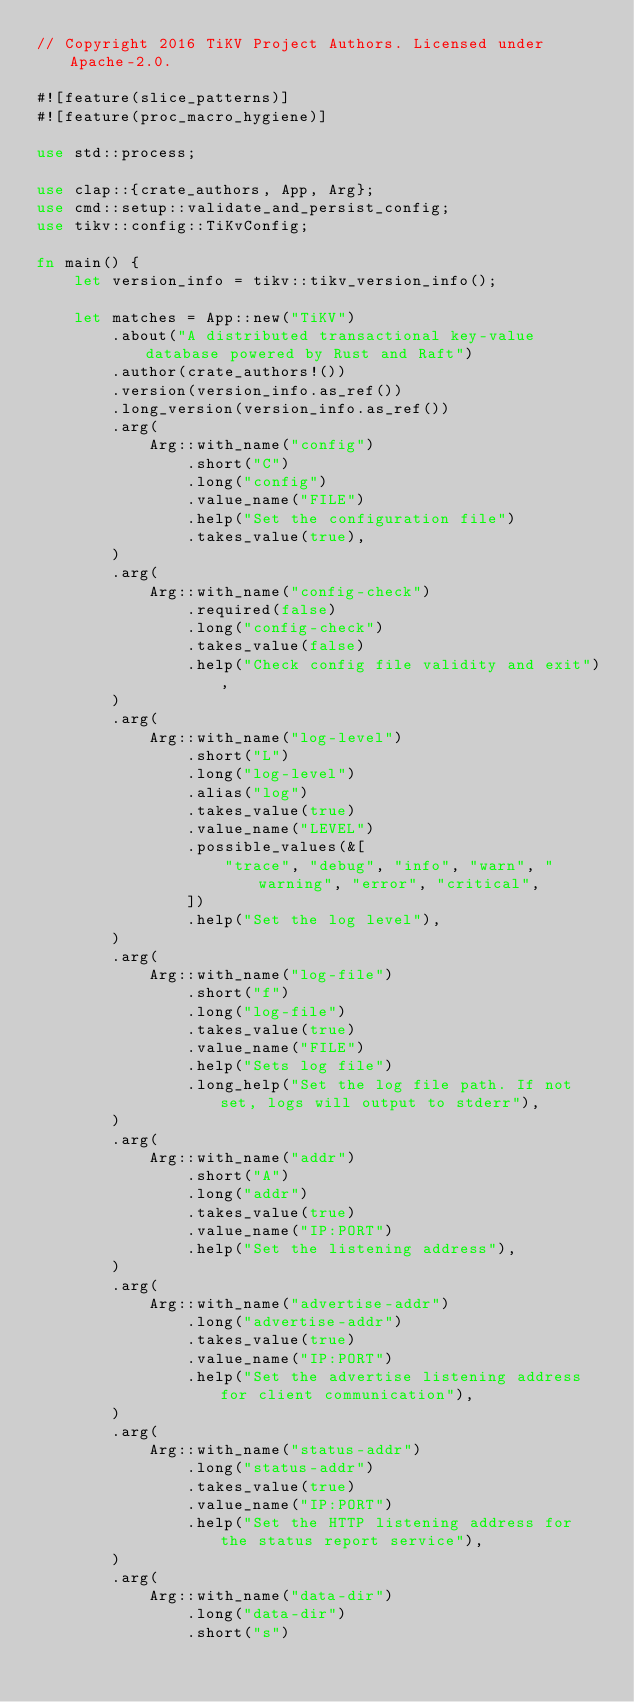Convert code to text. <code><loc_0><loc_0><loc_500><loc_500><_Rust_>// Copyright 2016 TiKV Project Authors. Licensed under Apache-2.0.

#![feature(slice_patterns)]
#![feature(proc_macro_hygiene)]

use std::process;

use clap::{crate_authors, App, Arg};
use cmd::setup::validate_and_persist_config;
use tikv::config::TiKvConfig;

fn main() {
    let version_info = tikv::tikv_version_info();

    let matches = App::new("TiKV")
        .about("A distributed transactional key-value database powered by Rust and Raft")
        .author(crate_authors!())
        .version(version_info.as_ref())
        .long_version(version_info.as_ref())
        .arg(
            Arg::with_name("config")
                .short("C")
                .long("config")
                .value_name("FILE")
                .help("Set the configuration file")
                .takes_value(true),
        )
        .arg(
            Arg::with_name("config-check")
                .required(false)
                .long("config-check")
                .takes_value(false)
                .help("Check config file validity and exit"),
        )
        .arg(
            Arg::with_name("log-level")
                .short("L")
                .long("log-level")
                .alias("log")
                .takes_value(true)
                .value_name("LEVEL")
                .possible_values(&[
                    "trace", "debug", "info", "warn", "warning", "error", "critical",
                ])
                .help("Set the log level"),
        )
        .arg(
            Arg::with_name("log-file")
                .short("f")
                .long("log-file")
                .takes_value(true)
                .value_name("FILE")
                .help("Sets log file")
                .long_help("Set the log file path. If not set, logs will output to stderr"),
        )
        .arg(
            Arg::with_name("addr")
                .short("A")
                .long("addr")
                .takes_value(true)
                .value_name("IP:PORT")
                .help("Set the listening address"),
        )
        .arg(
            Arg::with_name("advertise-addr")
                .long("advertise-addr")
                .takes_value(true)
                .value_name("IP:PORT")
                .help("Set the advertise listening address for client communication"),
        )
        .arg(
            Arg::with_name("status-addr")
                .long("status-addr")
                .takes_value(true)
                .value_name("IP:PORT")
                .help("Set the HTTP listening address for the status report service"),
        )
        .arg(
            Arg::with_name("data-dir")
                .long("data-dir")
                .short("s")</code> 